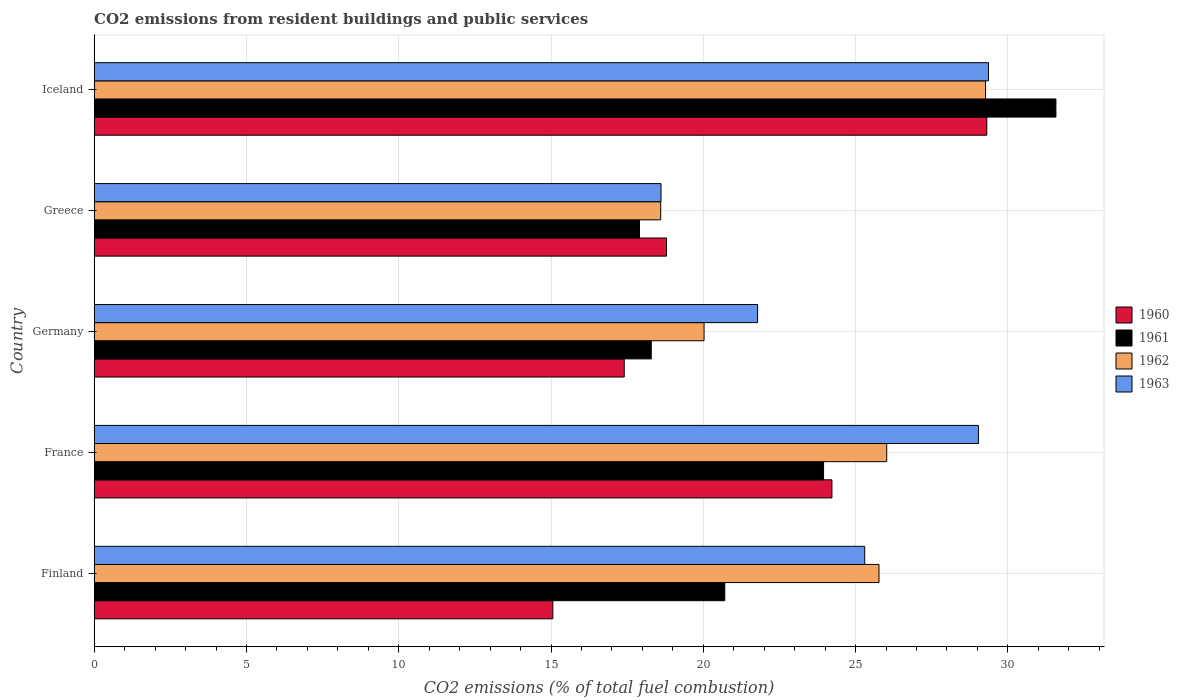Are the number of bars on each tick of the Y-axis equal?
Offer a terse response. Yes. How many bars are there on the 5th tick from the top?
Make the answer very short. 4. What is the total CO2 emitted in 1963 in Finland?
Provide a succinct answer. 25.3. Across all countries, what is the maximum total CO2 emitted in 1960?
Provide a succinct answer. 29.31. Across all countries, what is the minimum total CO2 emitted in 1960?
Your answer should be very brief. 15.06. In which country was the total CO2 emitted in 1963 minimum?
Offer a terse response. Greece. What is the total total CO2 emitted in 1962 in the graph?
Offer a very short reply. 119.69. What is the difference between the total CO2 emitted in 1961 in France and that in Germany?
Make the answer very short. 5.66. What is the difference between the total CO2 emitted in 1962 in France and the total CO2 emitted in 1961 in Germany?
Ensure brevity in your answer.  7.73. What is the average total CO2 emitted in 1961 per country?
Give a very brief answer. 22.49. What is the difference between the total CO2 emitted in 1963 and total CO2 emitted in 1962 in Greece?
Offer a terse response. 0.01. What is the ratio of the total CO2 emitted in 1962 in France to that in Iceland?
Your response must be concise. 0.89. What is the difference between the highest and the second highest total CO2 emitted in 1963?
Keep it short and to the point. 0.33. What is the difference between the highest and the lowest total CO2 emitted in 1963?
Ensure brevity in your answer.  10.75. Is the sum of the total CO2 emitted in 1962 in Germany and Iceland greater than the maximum total CO2 emitted in 1963 across all countries?
Make the answer very short. Yes. Is it the case that in every country, the sum of the total CO2 emitted in 1961 and total CO2 emitted in 1963 is greater than the total CO2 emitted in 1962?
Give a very brief answer. Yes. Are all the bars in the graph horizontal?
Offer a very short reply. Yes. How many countries are there in the graph?
Keep it short and to the point. 5. What is the difference between two consecutive major ticks on the X-axis?
Offer a terse response. 5. Are the values on the major ticks of X-axis written in scientific E-notation?
Your answer should be very brief. No. Where does the legend appear in the graph?
Provide a succinct answer. Center right. How are the legend labels stacked?
Your answer should be very brief. Vertical. What is the title of the graph?
Offer a terse response. CO2 emissions from resident buildings and public services. What is the label or title of the X-axis?
Keep it short and to the point. CO2 emissions (% of total fuel combustion). What is the CO2 emissions (% of total fuel combustion) of 1960 in Finland?
Offer a terse response. 15.06. What is the CO2 emissions (% of total fuel combustion) of 1961 in Finland?
Ensure brevity in your answer.  20.71. What is the CO2 emissions (% of total fuel combustion) in 1962 in Finland?
Your answer should be very brief. 25.77. What is the CO2 emissions (% of total fuel combustion) of 1963 in Finland?
Your answer should be very brief. 25.3. What is the CO2 emissions (% of total fuel combustion) in 1960 in France?
Your response must be concise. 24.22. What is the CO2 emissions (% of total fuel combustion) in 1961 in France?
Make the answer very short. 23.95. What is the CO2 emissions (% of total fuel combustion) of 1962 in France?
Ensure brevity in your answer.  26.02. What is the CO2 emissions (% of total fuel combustion) in 1963 in France?
Offer a terse response. 29.04. What is the CO2 emissions (% of total fuel combustion) in 1960 in Germany?
Offer a terse response. 17.4. What is the CO2 emissions (% of total fuel combustion) of 1961 in Germany?
Your response must be concise. 18.29. What is the CO2 emissions (% of total fuel combustion) in 1962 in Germany?
Ensure brevity in your answer.  20.03. What is the CO2 emissions (% of total fuel combustion) in 1963 in Germany?
Your response must be concise. 21.78. What is the CO2 emissions (% of total fuel combustion) in 1960 in Greece?
Provide a succinct answer. 18.79. What is the CO2 emissions (% of total fuel combustion) of 1961 in Greece?
Provide a short and direct response. 17.9. What is the CO2 emissions (% of total fuel combustion) in 1962 in Greece?
Provide a short and direct response. 18.6. What is the CO2 emissions (% of total fuel combustion) in 1963 in Greece?
Offer a terse response. 18.61. What is the CO2 emissions (% of total fuel combustion) in 1960 in Iceland?
Your response must be concise. 29.31. What is the CO2 emissions (% of total fuel combustion) of 1961 in Iceland?
Provide a short and direct response. 31.58. What is the CO2 emissions (% of total fuel combustion) in 1962 in Iceland?
Your response must be concise. 29.27. What is the CO2 emissions (% of total fuel combustion) of 1963 in Iceland?
Make the answer very short. 29.37. Across all countries, what is the maximum CO2 emissions (% of total fuel combustion) in 1960?
Provide a short and direct response. 29.31. Across all countries, what is the maximum CO2 emissions (% of total fuel combustion) of 1961?
Keep it short and to the point. 31.58. Across all countries, what is the maximum CO2 emissions (% of total fuel combustion) in 1962?
Your answer should be very brief. 29.27. Across all countries, what is the maximum CO2 emissions (% of total fuel combustion) in 1963?
Your response must be concise. 29.37. Across all countries, what is the minimum CO2 emissions (% of total fuel combustion) in 1960?
Give a very brief answer. 15.06. Across all countries, what is the minimum CO2 emissions (% of total fuel combustion) of 1961?
Offer a terse response. 17.9. Across all countries, what is the minimum CO2 emissions (% of total fuel combustion) in 1962?
Keep it short and to the point. 18.6. Across all countries, what is the minimum CO2 emissions (% of total fuel combustion) of 1963?
Your response must be concise. 18.61. What is the total CO2 emissions (% of total fuel combustion) of 1960 in the graph?
Your answer should be very brief. 104.79. What is the total CO2 emissions (% of total fuel combustion) in 1961 in the graph?
Your answer should be compact. 112.43. What is the total CO2 emissions (% of total fuel combustion) in 1962 in the graph?
Your answer should be very brief. 119.69. What is the total CO2 emissions (% of total fuel combustion) in 1963 in the graph?
Provide a succinct answer. 124.1. What is the difference between the CO2 emissions (% of total fuel combustion) of 1960 in Finland and that in France?
Your answer should be compact. -9.16. What is the difference between the CO2 emissions (% of total fuel combustion) of 1961 in Finland and that in France?
Give a very brief answer. -3.24. What is the difference between the CO2 emissions (% of total fuel combustion) of 1962 in Finland and that in France?
Your answer should be very brief. -0.25. What is the difference between the CO2 emissions (% of total fuel combustion) of 1963 in Finland and that in France?
Offer a terse response. -3.73. What is the difference between the CO2 emissions (% of total fuel combustion) in 1960 in Finland and that in Germany?
Give a very brief answer. -2.35. What is the difference between the CO2 emissions (% of total fuel combustion) in 1961 in Finland and that in Germany?
Provide a succinct answer. 2.41. What is the difference between the CO2 emissions (% of total fuel combustion) of 1962 in Finland and that in Germany?
Give a very brief answer. 5.74. What is the difference between the CO2 emissions (% of total fuel combustion) of 1963 in Finland and that in Germany?
Your response must be concise. 3.52. What is the difference between the CO2 emissions (% of total fuel combustion) in 1960 in Finland and that in Greece?
Your response must be concise. -3.73. What is the difference between the CO2 emissions (% of total fuel combustion) in 1961 in Finland and that in Greece?
Make the answer very short. 2.8. What is the difference between the CO2 emissions (% of total fuel combustion) of 1962 in Finland and that in Greece?
Give a very brief answer. 7.17. What is the difference between the CO2 emissions (% of total fuel combustion) of 1963 in Finland and that in Greece?
Keep it short and to the point. 6.69. What is the difference between the CO2 emissions (% of total fuel combustion) in 1960 in Finland and that in Iceland?
Ensure brevity in your answer.  -14.25. What is the difference between the CO2 emissions (% of total fuel combustion) of 1961 in Finland and that in Iceland?
Your answer should be compact. -10.87. What is the difference between the CO2 emissions (% of total fuel combustion) in 1962 in Finland and that in Iceland?
Give a very brief answer. -3.5. What is the difference between the CO2 emissions (% of total fuel combustion) in 1963 in Finland and that in Iceland?
Your response must be concise. -4.06. What is the difference between the CO2 emissions (% of total fuel combustion) in 1960 in France and that in Germany?
Offer a very short reply. 6.82. What is the difference between the CO2 emissions (% of total fuel combustion) of 1961 in France and that in Germany?
Your answer should be very brief. 5.66. What is the difference between the CO2 emissions (% of total fuel combustion) of 1962 in France and that in Germany?
Your answer should be very brief. 6. What is the difference between the CO2 emissions (% of total fuel combustion) of 1963 in France and that in Germany?
Offer a very short reply. 7.25. What is the difference between the CO2 emissions (% of total fuel combustion) in 1960 in France and that in Greece?
Provide a succinct answer. 5.43. What is the difference between the CO2 emissions (% of total fuel combustion) of 1961 in France and that in Greece?
Give a very brief answer. 6.05. What is the difference between the CO2 emissions (% of total fuel combustion) of 1962 in France and that in Greece?
Make the answer very short. 7.42. What is the difference between the CO2 emissions (% of total fuel combustion) in 1963 in France and that in Greece?
Make the answer very short. 10.42. What is the difference between the CO2 emissions (% of total fuel combustion) of 1960 in France and that in Iceland?
Offer a very short reply. -5.09. What is the difference between the CO2 emissions (% of total fuel combustion) in 1961 in France and that in Iceland?
Provide a succinct answer. -7.63. What is the difference between the CO2 emissions (% of total fuel combustion) in 1962 in France and that in Iceland?
Offer a very short reply. -3.24. What is the difference between the CO2 emissions (% of total fuel combustion) of 1963 in France and that in Iceland?
Your answer should be very brief. -0.33. What is the difference between the CO2 emissions (% of total fuel combustion) in 1960 in Germany and that in Greece?
Keep it short and to the point. -1.39. What is the difference between the CO2 emissions (% of total fuel combustion) in 1961 in Germany and that in Greece?
Provide a short and direct response. 0.39. What is the difference between the CO2 emissions (% of total fuel combustion) in 1962 in Germany and that in Greece?
Provide a succinct answer. 1.42. What is the difference between the CO2 emissions (% of total fuel combustion) of 1963 in Germany and that in Greece?
Keep it short and to the point. 3.17. What is the difference between the CO2 emissions (% of total fuel combustion) in 1960 in Germany and that in Iceland?
Offer a very short reply. -11.91. What is the difference between the CO2 emissions (% of total fuel combustion) of 1961 in Germany and that in Iceland?
Ensure brevity in your answer.  -13.29. What is the difference between the CO2 emissions (% of total fuel combustion) in 1962 in Germany and that in Iceland?
Offer a terse response. -9.24. What is the difference between the CO2 emissions (% of total fuel combustion) in 1963 in Germany and that in Iceland?
Offer a very short reply. -7.58. What is the difference between the CO2 emissions (% of total fuel combustion) of 1960 in Greece and that in Iceland?
Make the answer very short. -10.52. What is the difference between the CO2 emissions (% of total fuel combustion) in 1961 in Greece and that in Iceland?
Give a very brief answer. -13.67. What is the difference between the CO2 emissions (% of total fuel combustion) of 1962 in Greece and that in Iceland?
Give a very brief answer. -10.67. What is the difference between the CO2 emissions (% of total fuel combustion) in 1963 in Greece and that in Iceland?
Provide a short and direct response. -10.75. What is the difference between the CO2 emissions (% of total fuel combustion) of 1960 in Finland and the CO2 emissions (% of total fuel combustion) of 1961 in France?
Your response must be concise. -8.89. What is the difference between the CO2 emissions (% of total fuel combustion) in 1960 in Finland and the CO2 emissions (% of total fuel combustion) in 1962 in France?
Your answer should be very brief. -10.96. What is the difference between the CO2 emissions (% of total fuel combustion) in 1960 in Finland and the CO2 emissions (% of total fuel combustion) in 1963 in France?
Provide a succinct answer. -13.98. What is the difference between the CO2 emissions (% of total fuel combustion) of 1961 in Finland and the CO2 emissions (% of total fuel combustion) of 1962 in France?
Your answer should be compact. -5.32. What is the difference between the CO2 emissions (% of total fuel combustion) of 1961 in Finland and the CO2 emissions (% of total fuel combustion) of 1963 in France?
Ensure brevity in your answer.  -8.33. What is the difference between the CO2 emissions (% of total fuel combustion) of 1962 in Finland and the CO2 emissions (% of total fuel combustion) of 1963 in France?
Keep it short and to the point. -3.27. What is the difference between the CO2 emissions (% of total fuel combustion) of 1960 in Finland and the CO2 emissions (% of total fuel combustion) of 1961 in Germany?
Give a very brief answer. -3.23. What is the difference between the CO2 emissions (% of total fuel combustion) in 1960 in Finland and the CO2 emissions (% of total fuel combustion) in 1962 in Germany?
Give a very brief answer. -4.97. What is the difference between the CO2 emissions (% of total fuel combustion) in 1960 in Finland and the CO2 emissions (% of total fuel combustion) in 1963 in Germany?
Keep it short and to the point. -6.72. What is the difference between the CO2 emissions (% of total fuel combustion) in 1961 in Finland and the CO2 emissions (% of total fuel combustion) in 1962 in Germany?
Your response must be concise. 0.68. What is the difference between the CO2 emissions (% of total fuel combustion) in 1961 in Finland and the CO2 emissions (% of total fuel combustion) in 1963 in Germany?
Your response must be concise. -1.08. What is the difference between the CO2 emissions (% of total fuel combustion) in 1962 in Finland and the CO2 emissions (% of total fuel combustion) in 1963 in Germany?
Ensure brevity in your answer.  3.99. What is the difference between the CO2 emissions (% of total fuel combustion) in 1960 in Finland and the CO2 emissions (% of total fuel combustion) in 1961 in Greece?
Your response must be concise. -2.85. What is the difference between the CO2 emissions (% of total fuel combustion) of 1960 in Finland and the CO2 emissions (% of total fuel combustion) of 1962 in Greece?
Ensure brevity in your answer.  -3.54. What is the difference between the CO2 emissions (% of total fuel combustion) of 1960 in Finland and the CO2 emissions (% of total fuel combustion) of 1963 in Greece?
Your response must be concise. -3.55. What is the difference between the CO2 emissions (% of total fuel combustion) in 1961 in Finland and the CO2 emissions (% of total fuel combustion) in 1962 in Greece?
Ensure brevity in your answer.  2.1. What is the difference between the CO2 emissions (% of total fuel combustion) in 1961 in Finland and the CO2 emissions (% of total fuel combustion) in 1963 in Greece?
Your answer should be very brief. 2.09. What is the difference between the CO2 emissions (% of total fuel combustion) of 1962 in Finland and the CO2 emissions (% of total fuel combustion) of 1963 in Greece?
Ensure brevity in your answer.  7.16. What is the difference between the CO2 emissions (% of total fuel combustion) in 1960 in Finland and the CO2 emissions (% of total fuel combustion) in 1961 in Iceland?
Your answer should be very brief. -16.52. What is the difference between the CO2 emissions (% of total fuel combustion) of 1960 in Finland and the CO2 emissions (% of total fuel combustion) of 1962 in Iceland?
Provide a short and direct response. -14.21. What is the difference between the CO2 emissions (% of total fuel combustion) of 1960 in Finland and the CO2 emissions (% of total fuel combustion) of 1963 in Iceland?
Ensure brevity in your answer.  -14.31. What is the difference between the CO2 emissions (% of total fuel combustion) in 1961 in Finland and the CO2 emissions (% of total fuel combustion) in 1962 in Iceland?
Keep it short and to the point. -8.56. What is the difference between the CO2 emissions (% of total fuel combustion) in 1961 in Finland and the CO2 emissions (% of total fuel combustion) in 1963 in Iceland?
Your response must be concise. -8.66. What is the difference between the CO2 emissions (% of total fuel combustion) in 1962 in Finland and the CO2 emissions (% of total fuel combustion) in 1963 in Iceland?
Your response must be concise. -3.6. What is the difference between the CO2 emissions (% of total fuel combustion) in 1960 in France and the CO2 emissions (% of total fuel combustion) in 1961 in Germany?
Make the answer very short. 5.93. What is the difference between the CO2 emissions (% of total fuel combustion) in 1960 in France and the CO2 emissions (% of total fuel combustion) in 1962 in Germany?
Provide a short and direct response. 4.2. What is the difference between the CO2 emissions (% of total fuel combustion) of 1960 in France and the CO2 emissions (% of total fuel combustion) of 1963 in Germany?
Offer a terse response. 2.44. What is the difference between the CO2 emissions (% of total fuel combustion) of 1961 in France and the CO2 emissions (% of total fuel combustion) of 1962 in Germany?
Your response must be concise. 3.92. What is the difference between the CO2 emissions (% of total fuel combustion) of 1961 in France and the CO2 emissions (% of total fuel combustion) of 1963 in Germany?
Provide a short and direct response. 2.17. What is the difference between the CO2 emissions (% of total fuel combustion) of 1962 in France and the CO2 emissions (% of total fuel combustion) of 1963 in Germany?
Keep it short and to the point. 4.24. What is the difference between the CO2 emissions (% of total fuel combustion) of 1960 in France and the CO2 emissions (% of total fuel combustion) of 1961 in Greece?
Provide a short and direct response. 6.32. What is the difference between the CO2 emissions (% of total fuel combustion) in 1960 in France and the CO2 emissions (% of total fuel combustion) in 1962 in Greece?
Make the answer very short. 5.62. What is the difference between the CO2 emissions (% of total fuel combustion) of 1960 in France and the CO2 emissions (% of total fuel combustion) of 1963 in Greece?
Make the answer very short. 5.61. What is the difference between the CO2 emissions (% of total fuel combustion) of 1961 in France and the CO2 emissions (% of total fuel combustion) of 1962 in Greece?
Ensure brevity in your answer.  5.35. What is the difference between the CO2 emissions (% of total fuel combustion) in 1961 in France and the CO2 emissions (% of total fuel combustion) in 1963 in Greece?
Offer a very short reply. 5.34. What is the difference between the CO2 emissions (% of total fuel combustion) of 1962 in France and the CO2 emissions (% of total fuel combustion) of 1963 in Greece?
Your answer should be very brief. 7.41. What is the difference between the CO2 emissions (% of total fuel combustion) in 1960 in France and the CO2 emissions (% of total fuel combustion) in 1961 in Iceland?
Make the answer very short. -7.35. What is the difference between the CO2 emissions (% of total fuel combustion) of 1960 in France and the CO2 emissions (% of total fuel combustion) of 1962 in Iceland?
Give a very brief answer. -5.04. What is the difference between the CO2 emissions (% of total fuel combustion) in 1960 in France and the CO2 emissions (% of total fuel combustion) in 1963 in Iceland?
Ensure brevity in your answer.  -5.14. What is the difference between the CO2 emissions (% of total fuel combustion) in 1961 in France and the CO2 emissions (% of total fuel combustion) in 1962 in Iceland?
Your answer should be very brief. -5.32. What is the difference between the CO2 emissions (% of total fuel combustion) of 1961 in France and the CO2 emissions (% of total fuel combustion) of 1963 in Iceland?
Your answer should be very brief. -5.41. What is the difference between the CO2 emissions (% of total fuel combustion) of 1962 in France and the CO2 emissions (% of total fuel combustion) of 1963 in Iceland?
Make the answer very short. -3.34. What is the difference between the CO2 emissions (% of total fuel combustion) in 1960 in Germany and the CO2 emissions (% of total fuel combustion) in 1961 in Greece?
Keep it short and to the point. -0.5. What is the difference between the CO2 emissions (% of total fuel combustion) in 1960 in Germany and the CO2 emissions (% of total fuel combustion) in 1962 in Greece?
Give a very brief answer. -1.2. What is the difference between the CO2 emissions (% of total fuel combustion) of 1960 in Germany and the CO2 emissions (% of total fuel combustion) of 1963 in Greece?
Keep it short and to the point. -1.21. What is the difference between the CO2 emissions (% of total fuel combustion) in 1961 in Germany and the CO2 emissions (% of total fuel combustion) in 1962 in Greece?
Your answer should be very brief. -0.31. What is the difference between the CO2 emissions (% of total fuel combustion) in 1961 in Germany and the CO2 emissions (% of total fuel combustion) in 1963 in Greece?
Provide a short and direct response. -0.32. What is the difference between the CO2 emissions (% of total fuel combustion) in 1962 in Germany and the CO2 emissions (% of total fuel combustion) in 1963 in Greece?
Ensure brevity in your answer.  1.41. What is the difference between the CO2 emissions (% of total fuel combustion) in 1960 in Germany and the CO2 emissions (% of total fuel combustion) in 1961 in Iceland?
Keep it short and to the point. -14.17. What is the difference between the CO2 emissions (% of total fuel combustion) of 1960 in Germany and the CO2 emissions (% of total fuel combustion) of 1962 in Iceland?
Offer a very short reply. -11.86. What is the difference between the CO2 emissions (% of total fuel combustion) of 1960 in Germany and the CO2 emissions (% of total fuel combustion) of 1963 in Iceland?
Your answer should be very brief. -11.96. What is the difference between the CO2 emissions (% of total fuel combustion) of 1961 in Germany and the CO2 emissions (% of total fuel combustion) of 1962 in Iceland?
Your answer should be very brief. -10.98. What is the difference between the CO2 emissions (% of total fuel combustion) of 1961 in Germany and the CO2 emissions (% of total fuel combustion) of 1963 in Iceland?
Give a very brief answer. -11.07. What is the difference between the CO2 emissions (% of total fuel combustion) in 1962 in Germany and the CO2 emissions (% of total fuel combustion) in 1963 in Iceland?
Your answer should be compact. -9.34. What is the difference between the CO2 emissions (% of total fuel combustion) of 1960 in Greece and the CO2 emissions (% of total fuel combustion) of 1961 in Iceland?
Give a very brief answer. -12.79. What is the difference between the CO2 emissions (% of total fuel combustion) of 1960 in Greece and the CO2 emissions (% of total fuel combustion) of 1962 in Iceland?
Provide a succinct answer. -10.48. What is the difference between the CO2 emissions (% of total fuel combustion) of 1960 in Greece and the CO2 emissions (% of total fuel combustion) of 1963 in Iceland?
Ensure brevity in your answer.  -10.57. What is the difference between the CO2 emissions (% of total fuel combustion) of 1961 in Greece and the CO2 emissions (% of total fuel combustion) of 1962 in Iceland?
Your answer should be compact. -11.36. What is the difference between the CO2 emissions (% of total fuel combustion) of 1961 in Greece and the CO2 emissions (% of total fuel combustion) of 1963 in Iceland?
Offer a very short reply. -11.46. What is the difference between the CO2 emissions (% of total fuel combustion) in 1962 in Greece and the CO2 emissions (% of total fuel combustion) in 1963 in Iceland?
Provide a short and direct response. -10.76. What is the average CO2 emissions (% of total fuel combustion) in 1960 per country?
Your answer should be compact. 20.96. What is the average CO2 emissions (% of total fuel combustion) in 1961 per country?
Your answer should be very brief. 22.49. What is the average CO2 emissions (% of total fuel combustion) in 1962 per country?
Give a very brief answer. 23.94. What is the average CO2 emissions (% of total fuel combustion) of 1963 per country?
Your answer should be very brief. 24.82. What is the difference between the CO2 emissions (% of total fuel combustion) of 1960 and CO2 emissions (% of total fuel combustion) of 1961 in Finland?
Offer a terse response. -5.65. What is the difference between the CO2 emissions (% of total fuel combustion) in 1960 and CO2 emissions (% of total fuel combustion) in 1962 in Finland?
Ensure brevity in your answer.  -10.71. What is the difference between the CO2 emissions (% of total fuel combustion) in 1960 and CO2 emissions (% of total fuel combustion) in 1963 in Finland?
Offer a terse response. -10.24. What is the difference between the CO2 emissions (% of total fuel combustion) of 1961 and CO2 emissions (% of total fuel combustion) of 1962 in Finland?
Ensure brevity in your answer.  -5.06. What is the difference between the CO2 emissions (% of total fuel combustion) in 1961 and CO2 emissions (% of total fuel combustion) in 1963 in Finland?
Provide a succinct answer. -4.59. What is the difference between the CO2 emissions (% of total fuel combustion) of 1962 and CO2 emissions (% of total fuel combustion) of 1963 in Finland?
Ensure brevity in your answer.  0.47. What is the difference between the CO2 emissions (% of total fuel combustion) of 1960 and CO2 emissions (% of total fuel combustion) of 1961 in France?
Provide a short and direct response. 0.27. What is the difference between the CO2 emissions (% of total fuel combustion) of 1960 and CO2 emissions (% of total fuel combustion) of 1962 in France?
Offer a terse response. -1.8. What is the difference between the CO2 emissions (% of total fuel combustion) in 1960 and CO2 emissions (% of total fuel combustion) in 1963 in France?
Your response must be concise. -4.81. What is the difference between the CO2 emissions (% of total fuel combustion) in 1961 and CO2 emissions (% of total fuel combustion) in 1962 in France?
Make the answer very short. -2.07. What is the difference between the CO2 emissions (% of total fuel combustion) of 1961 and CO2 emissions (% of total fuel combustion) of 1963 in France?
Ensure brevity in your answer.  -5.08. What is the difference between the CO2 emissions (% of total fuel combustion) of 1962 and CO2 emissions (% of total fuel combustion) of 1963 in France?
Provide a short and direct response. -3.01. What is the difference between the CO2 emissions (% of total fuel combustion) in 1960 and CO2 emissions (% of total fuel combustion) in 1961 in Germany?
Ensure brevity in your answer.  -0.89. What is the difference between the CO2 emissions (% of total fuel combustion) of 1960 and CO2 emissions (% of total fuel combustion) of 1962 in Germany?
Offer a terse response. -2.62. What is the difference between the CO2 emissions (% of total fuel combustion) in 1960 and CO2 emissions (% of total fuel combustion) in 1963 in Germany?
Your answer should be compact. -4.38. What is the difference between the CO2 emissions (% of total fuel combustion) in 1961 and CO2 emissions (% of total fuel combustion) in 1962 in Germany?
Make the answer very short. -1.73. What is the difference between the CO2 emissions (% of total fuel combustion) in 1961 and CO2 emissions (% of total fuel combustion) in 1963 in Germany?
Your response must be concise. -3.49. What is the difference between the CO2 emissions (% of total fuel combustion) in 1962 and CO2 emissions (% of total fuel combustion) in 1963 in Germany?
Keep it short and to the point. -1.76. What is the difference between the CO2 emissions (% of total fuel combustion) of 1960 and CO2 emissions (% of total fuel combustion) of 1961 in Greece?
Provide a short and direct response. 0.89. What is the difference between the CO2 emissions (% of total fuel combustion) in 1960 and CO2 emissions (% of total fuel combustion) in 1962 in Greece?
Offer a terse response. 0.19. What is the difference between the CO2 emissions (% of total fuel combustion) of 1960 and CO2 emissions (% of total fuel combustion) of 1963 in Greece?
Provide a succinct answer. 0.18. What is the difference between the CO2 emissions (% of total fuel combustion) of 1961 and CO2 emissions (% of total fuel combustion) of 1962 in Greece?
Your answer should be very brief. -0.7. What is the difference between the CO2 emissions (% of total fuel combustion) in 1961 and CO2 emissions (% of total fuel combustion) in 1963 in Greece?
Ensure brevity in your answer.  -0.71. What is the difference between the CO2 emissions (% of total fuel combustion) in 1962 and CO2 emissions (% of total fuel combustion) in 1963 in Greece?
Your answer should be compact. -0.01. What is the difference between the CO2 emissions (% of total fuel combustion) in 1960 and CO2 emissions (% of total fuel combustion) in 1961 in Iceland?
Provide a short and direct response. -2.27. What is the difference between the CO2 emissions (% of total fuel combustion) of 1960 and CO2 emissions (% of total fuel combustion) of 1962 in Iceland?
Make the answer very short. 0.04. What is the difference between the CO2 emissions (% of total fuel combustion) of 1960 and CO2 emissions (% of total fuel combustion) of 1963 in Iceland?
Provide a succinct answer. -0.05. What is the difference between the CO2 emissions (% of total fuel combustion) in 1961 and CO2 emissions (% of total fuel combustion) in 1962 in Iceland?
Offer a very short reply. 2.31. What is the difference between the CO2 emissions (% of total fuel combustion) of 1961 and CO2 emissions (% of total fuel combustion) of 1963 in Iceland?
Give a very brief answer. 2.21. What is the difference between the CO2 emissions (% of total fuel combustion) in 1962 and CO2 emissions (% of total fuel combustion) in 1963 in Iceland?
Offer a very short reply. -0.1. What is the ratio of the CO2 emissions (% of total fuel combustion) in 1960 in Finland to that in France?
Your response must be concise. 0.62. What is the ratio of the CO2 emissions (% of total fuel combustion) of 1961 in Finland to that in France?
Provide a succinct answer. 0.86. What is the ratio of the CO2 emissions (% of total fuel combustion) in 1962 in Finland to that in France?
Keep it short and to the point. 0.99. What is the ratio of the CO2 emissions (% of total fuel combustion) of 1963 in Finland to that in France?
Offer a very short reply. 0.87. What is the ratio of the CO2 emissions (% of total fuel combustion) of 1960 in Finland to that in Germany?
Your response must be concise. 0.87. What is the ratio of the CO2 emissions (% of total fuel combustion) of 1961 in Finland to that in Germany?
Keep it short and to the point. 1.13. What is the ratio of the CO2 emissions (% of total fuel combustion) of 1962 in Finland to that in Germany?
Offer a terse response. 1.29. What is the ratio of the CO2 emissions (% of total fuel combustion) in 1963 in Finland to that in Germany?
Provide a short and direct response. 1.16. What is the ratio of the CO2 emissions (% of total fuel combustion) of 1960 in Finland to that in Greece?
Offer a very short reply. 0.8. What is the ratio of the CO2 emissions (% of total fuel combustion) in 1961 in Finland to that in Greece?
Keep it short and to the point. 1.16. What is the ratio of the CO2 emissions (% of total fuel combustion) of 1962 in Finland to that in Greece?
Provide a short and direct response. 1.39. What is the ratio of the CO2 emissions (% of total fuel combustion) in 1963 in Finland to that in Greece?
Offer a terse response. 1.36. What is the ratio of the CO2 emissions (% of total fuel combustion) in 1960 in Finland to that in Iceland?
Your answer should be compact. 0.51. What is the ratio of the CO2 emissions (% of total fuel combustion) of 1961 in Finland to that in Iceland?
Your answer should be compact. 0.66. What is the ratio of the CO2 emissions (% of total fuel combustion) in 1962 in Finland to that in Iceland?
Give a very brief answer. 0.88. What is the ratio of the CO2 emissions (% of total fuel combustion) of 1963 in Finland to that in Iceland?
Ensure brevity in your answer.  0.86. What is the ratio of the CO2 emissions (% of total fuel combustion) in 1960 in France to that in Germany?
Give a very brief answer. 1.39. What is the ratio of the CO2 emissions (% of total fuel combustion) in 1961 in France to that in Germany?
Make the answer very short. 1.31. What is the ratio of the CO2 emissions (% of total fuel combustion) of 1962 in France to that in Germany?
Give a very brief answer. 1.3. What is the ratio of the CO2 emissions (% of total fuel combustion) of 1963 in France to that in Germany?
Your answer should be compact. 1.33. What is the ratio of the CO2 emissions (% of total fuel combustion) in 1960 in France to that in Greece?
Your answer should be very brief. 1.29. What is the ratio of the CO2 emissions (% of total fuel combustion) in 1961 in France to that in Greece?
Your answer should be very brief. 1.34. What is the ratio of the CO2 emissions (% of total fuel combustion) in 1962 in France to that in Greece?
Provide a short and direct response. 1.4. What is the ratio of the CO2 emissions (% of total fuel combustion) of 1963 in France to that in Greece?
Give a very brief answer. 1.56. What is the ratio of the CO2 emissions (% of total fuel combustion) of 1960 in France to that in Iceland?
Provide a short and direct response. 0.83. What is the ratio of the CO2 emissions (% of total fuel combustion) in 1961 in France to that in Iceland?
Make the answer very short. 0.76. What is the ratio of the CO2 emissions (% of total fuel combustion) of 1962 in France to that in Iceland?
Your answer should be very brief. 0.89. What is the ratio of the CO2 emissions (% of total fuel combustion) of 1963 in France to that in Iceland?
Your response must be concise. 0.99. What is the ratio of the CO2 emissions (% of total fuel combustion) of 1960 in Germany to that in Greece?
Offer a very short reply. 0.93. What is the ratio of the CO2 emissions (% of total fuel combustion) of 1961 in Germany to that in Greece?
Provide a short and direct response. 1.02. What is the ratio of the CO2 emissions (% of total fuel combustion) in 1962 in Germany to that in Greece?
Ensure brevity in your answer.  1.08. What is the ratio of the CO2 emissions (% of total fuel combustion) of 1963 in Germany to that in Greece?
Your answer should be very brief. 1.17. What is the ratio of the CO2 emissions (% of total fuel combustion) in 1960 in Germany to that in Iceland?
Make the answer very short. 0.59. What is the ratio of the CO2 emissions (% of total fuel combustion) in 1961 in Germany to that in Iceland?
Provide a short and direct response. 0.58. What is the ratio of the CO2 emissions (% of total fuel combustion) in 1962 in Germany to that in Iceland?
Provide a succinct answer. 0.68. What is the ratio of the CO2 emissions (% of total fuel combustion) of 1963 in Germany to that in Iceland?
Offer a very short reply. 0.74. What is the ratio of the CO2 emissions (% of total fuel combustion) in 1960 in Greece to that in Iceland?
Your response must be concise. 0.64. What is the ratio of the CO2 emissions (% of total fuel combustion) in 1961 in Greece to that in Iceland?
Make the answer very short. 0.57. What is the ratio of the CO2 emissions (% of total fuel combustion) of 1962 in Greece to that in Iceland?
Offer a very short reply. 0.64. What is the ratio of the CO2 emissions (% of total fuel combustion) of 1963 in Greece to that in Iceland?
Keep it short and to the point. 0.63. What is the difference between the highest and the second highest CO2 emissions (% of total fuel combustion) in 1960?
Your response must be concise. 5.09. What is the difference between the highest and the second highest CO2 emissions (% of total fuel combustion) of 1961?
Offer a terse response. 7.63. What is the difference between the highest and the second highest CO2 emissions (% of total fuel combustion) in 1962?
Make the answer very short. 3.24. What is the difference between the highest and the second highest CO2 emissions (% of total fuel combustion) of 1963?
Your answer should be very brief. 0.33. What is the difference between the highest and the lowest CO2 emissions (% of total fuel combustion) of 1960?
Provide a succinct answer. 14.25. What is the difference between the highest and the lowest CO2 emissions (% of total fuel combustion) of 1961?
Give a very brief answer. 13.67. What is the difference between the highest and the lowest CO2 emissions (% of total fuel combustion) in 1962?
Offer a very short reply. 10.67. What is the difference between the highest and the lowest CO2 emissions (% of total fuel combustion) in 1963?
Ensure brevity in your answer.  10.75. 